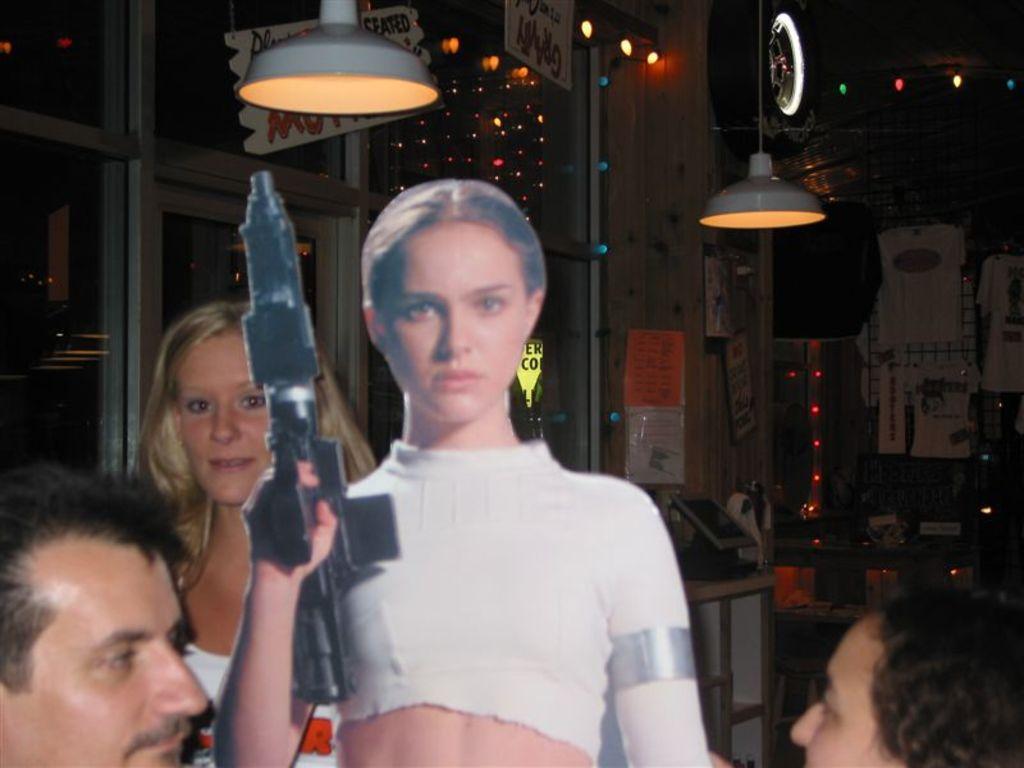How would you summarize this image in a sentence or two? On the left side, there is a person. Beside him, there is a cutout of a woman who is in a white color T-shirt and holding a gun. On the right side, there is another person. In the background, there are lights arranged, there is a woman smiling, there are windows and other objects. 